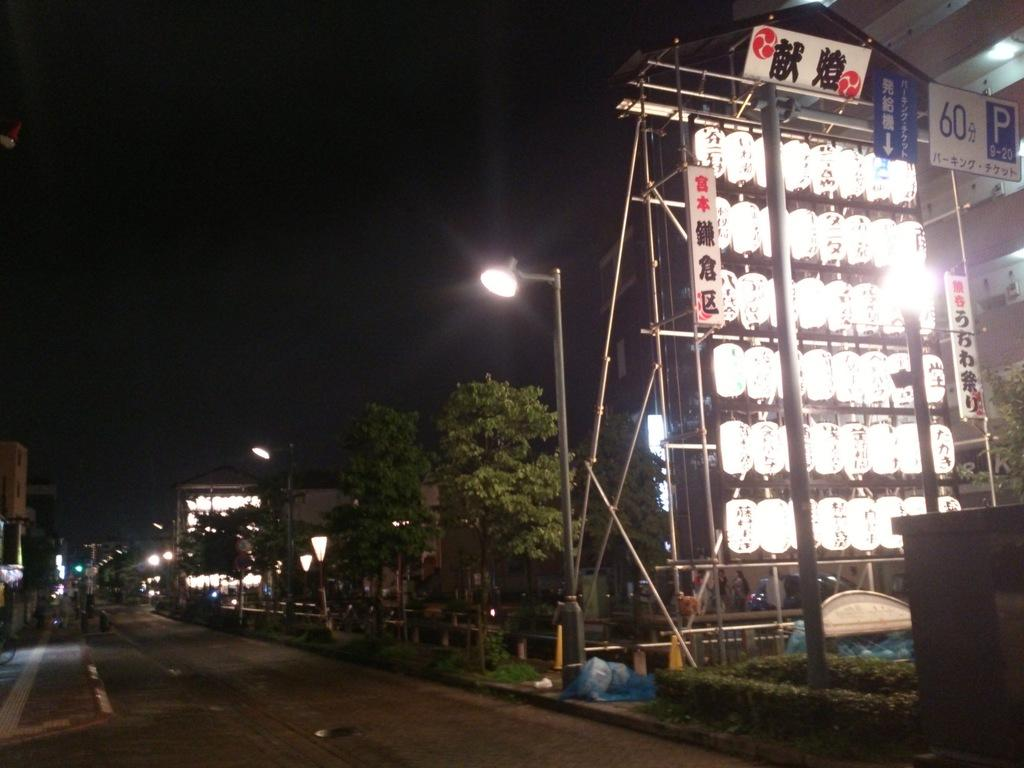<image>
Write a terse but informative summary of the picture. Signs on top of many lights and a number 60 as well. 